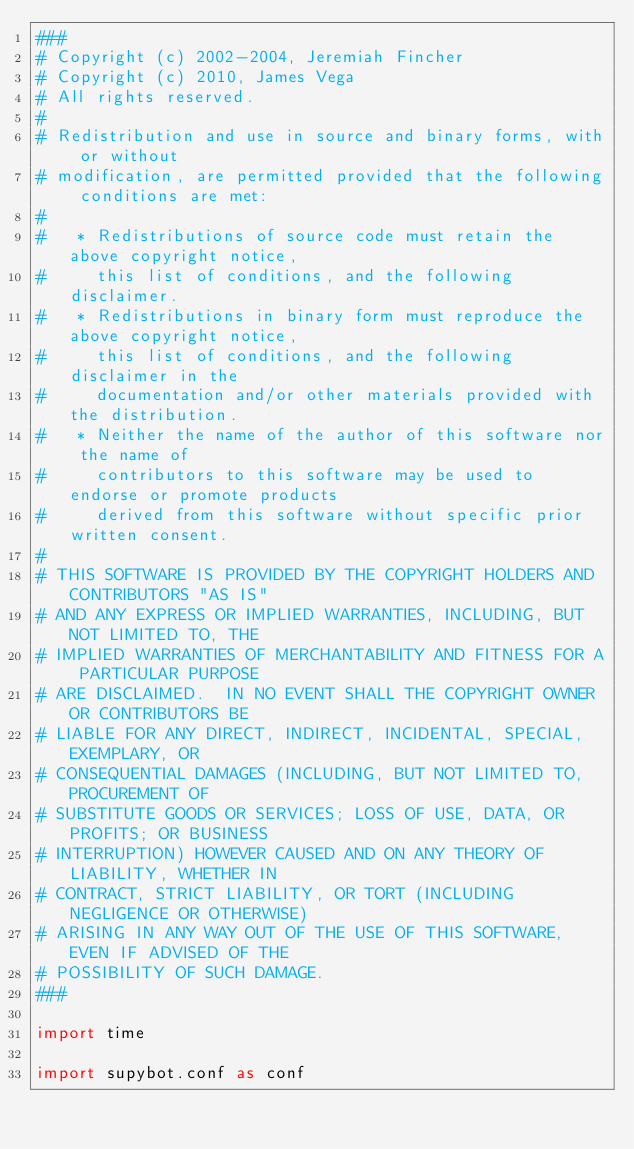Convert code to text. <code><loc_0><loc_0><loc_500><loc_500><_Python_>###
# Copyright (c) 2002-2004, Jeremiah Fincher
# Copyright (c) 2010, James Vega
# All rights reserved.
#
# Redistribution and use in source and binary forms, with or without
# modification, are permitted provided that the following conditions are met:
#
#   * Redistributions of source code must retain the above copyright notice,
#     this list of conditions, and the following disclaimer.
#   * Redistributions in binary form must reproduce the above copyright notice,
#     this list of conditions, and the following disclaimer in the
#     documentation and/or other materials provided with the distribution.
#   * Neither the name of the author of this software nor the name of
#     contributors to this software may be used to endorse or promote products
#     derived from this software without specific prior written consent.
#
# THIS SOFTWARE IS PROVIDED BY THE COPYRIGHT HOLDERS AND CONTRIBUTORS "AS IS"
# AND ANY EXPRESS OR IMPLIED WARRANTIES, INCLUDING, BUT NOT LIMITED TO, THE
# IMPLIED WARRANTIES OF MERCHANTABILITY AND FITNESS FOR A PARTICULAR PURPOSE
# ARE DISCLAIMED.  IN NO EVENT SHALL THE COPYRIGHT OWNER OR CONTRIBUTORS BE
# LIABLE FOR ANY DIRECT, INDIRECT, INCIDENTAL, SPECIAL, EXEMPLARY, OR
# CONSEQUENTIAL DAMAGES (INCLUDING, BUT NOT LIMITED TO, PROCUREMENT OF
# SUBSTITUTE GOODS OR SERVICES; LOSS OF USE, DATA, OR PROFITS; OR BUSINESS
# INTERRUPTION) HOWEVER CAUSED AND ON ANY THEORY OF LIABILITY, WHETHER IN
# CONTRACT, STRICT LIABILITY, OR TORT (INCLUDING NEGLIGENCE OR OTHERWISE)
# ARISING IN ANY WAY OUT OF THE USE OF THIS SOFTWARE, EVEN IF ADVISED OF THE
# POSSIBILITY OF SUCH DAMAGE.
###

import time

import supybot.conf as conf</code> 